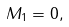Convert formula to latex. <formula><loc_0><loc_0><loc_500><loc_500>M _ { 1 } = 0 ,</formula> 